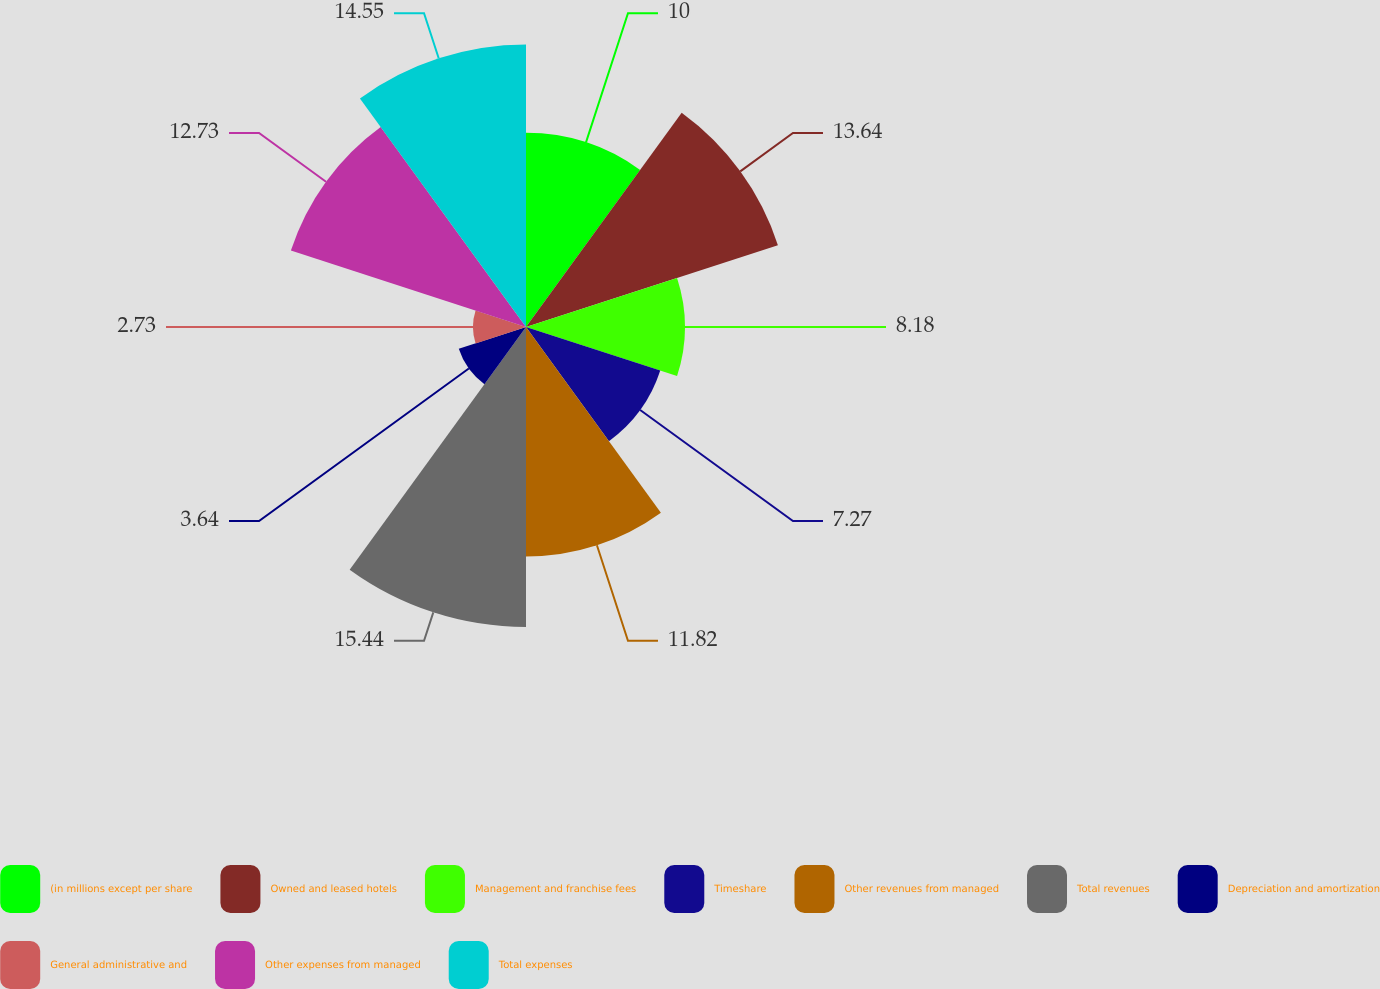Convert chart to OTSL. <chart><loc_0><loc_0><loc_500><loc_500><pie_chart><fcel>(in millions except per share<fcel>Owned and leased hotels<fcel>Management and franchise fees<fcel>Timeshare<fcel>Other revenues from managed<fcel>Total revenues<fcel>Depreciation and amortization<fcel>General administrative and<fcel>Other expenses from managed<fcel>Total expenses<nl><fcel>10.0%<fcel>13.64%<fcel>8.18%<fcel>7.27%<fcel>11.82%<fcel>15.45%<fcel>3.64%<fcel>2.73%<fcel>12.73%<fcel>14.55%<nl></chart> 